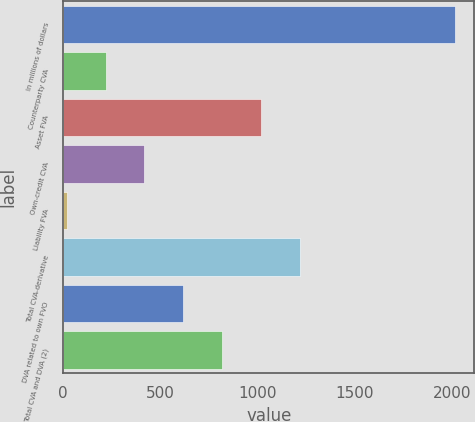Convert chart to OTSL. <chart><loc_0><loc_0><loc_500><loc_500><bar_chart><fcel>In millions of dollars<fcel>Counterparty CVA<fcel>Asset FVA<fcel>Own-credit CVA<fcel>Liability FVA<fcel>Total CVA-derivative<fcel>DVA related to own FVO<fcel>Total CVA and DVA (2)<nl><fcel>2014<fcel>218.5<fcel>1016.5<fcel>418<fcel>19<fcel>1216<fcel>617.5<fcel>817<nl></chart> 